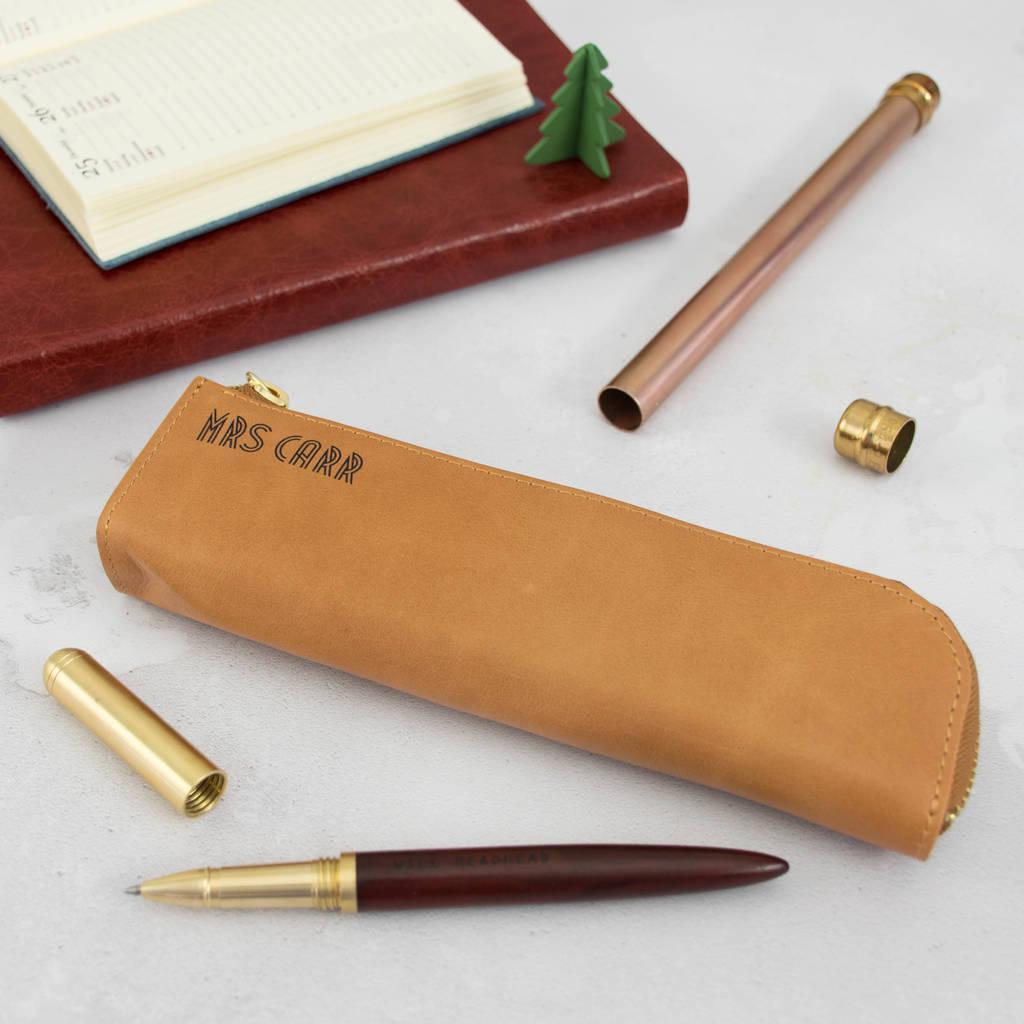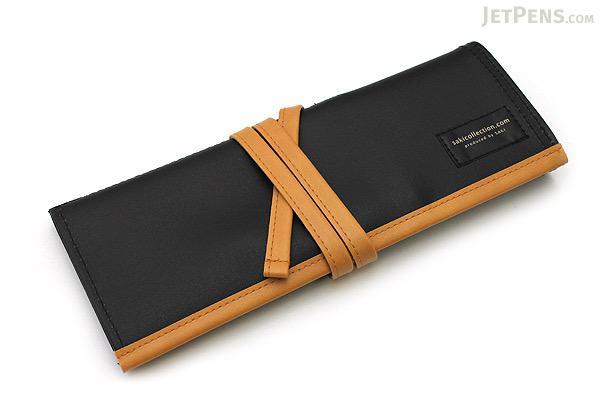The first image is the image on the left, the second image is the image on the right. Considering the images on both sides, is "The left image shows a pair of hands holding a zipper case featuring light-blue color and its contents." valid? Answer yes or no. No. The first image is the image on the left, the second image is the image on the right. Assess this claim about the two images: "One of the images features someone holding a pencil case.". Correct or not? Answer yes or no. No. 